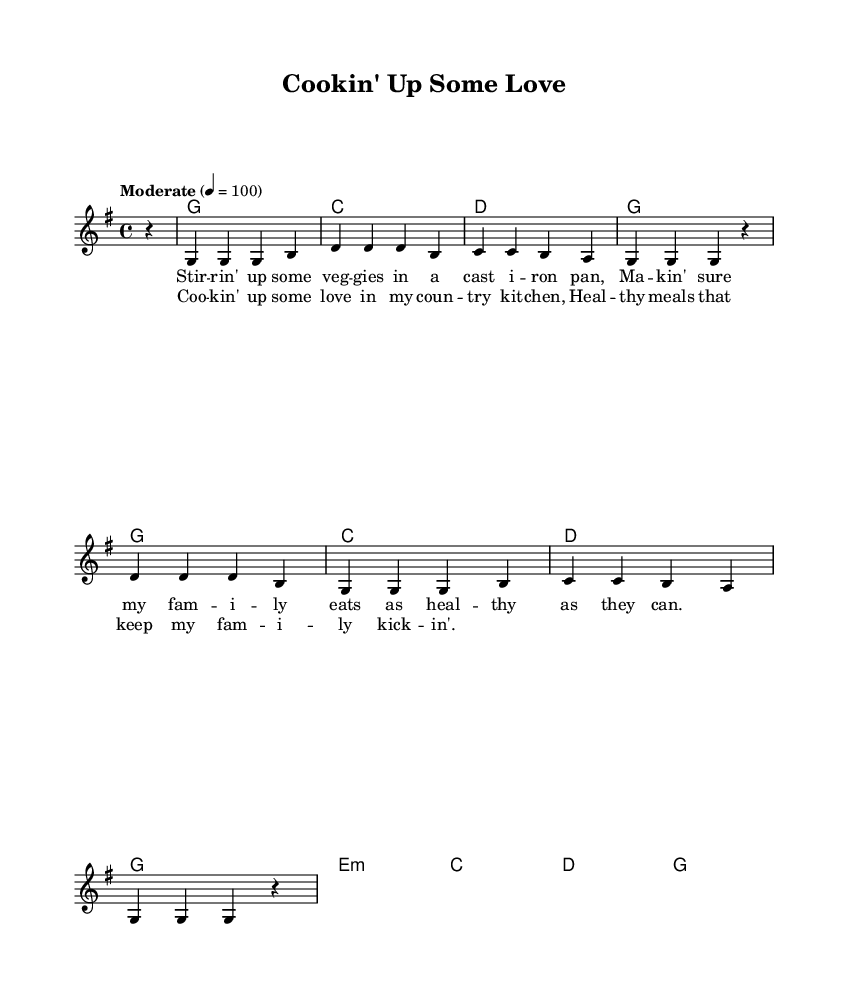What is the key signature of this music? The key signature is G major, which has one sharp (F#).
Answer: G major What is the time signature of the piece? The time signature is indicated as 4/4, meaning there are four beats in each measure.
Answer: 4/4 What is the tempo marking for this song? The tempo marking states "Moderate" with a metronome marking of 100 beats per minute.
Answer: Moderate How many measures are there in the verse? Counting the measures in the verse, there are four measures.
Answer: 4 What is the first chord in the harmonies section? The first chord written in the harmonies section is G major, which is indicated as "g1".
Answer: G What is the central theme of the lyrics? The lyrics focus on preparing healthy meals for the family, emphasizing love and nutrition.
Answer: Healthy meals What is the rhyme scheme used in the chorus? The rhyme scheme of the chorus follows an AABB pattern, where lines 1 and 2 rhyme and lines 3 and 4 rhyme.
Answer: AABB 